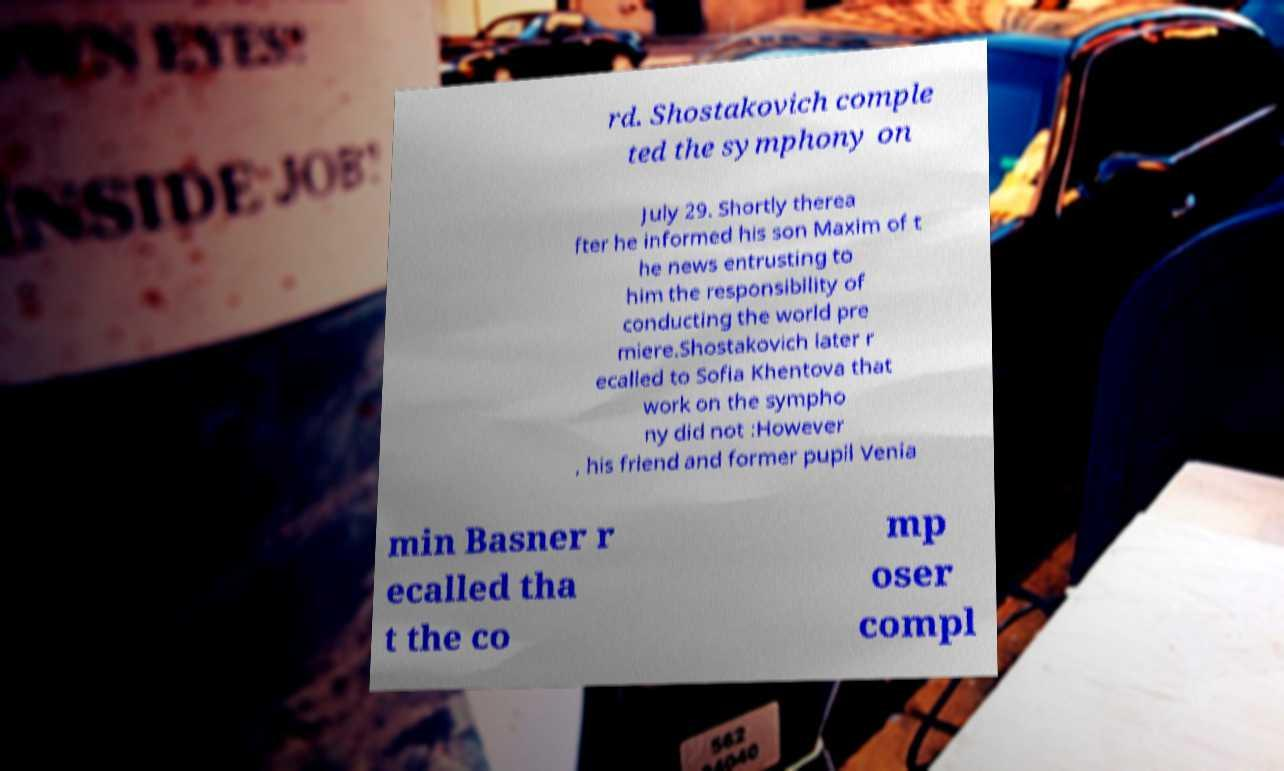What messages or text are displayed in this image? I need them in a readable, typed format. rd. Shostakovich comple ted the symphony on July 29. Shortly therea fter he informed his son Maxim of t he news entrusting to him the responsibility of conducting the world pre miere.Shostakovich later r ecalled to Sofia Khentova that work on the sympho ny did not :However , his friend and former pupil Venia min Basner r ecalled tha t the co mp oser compl 